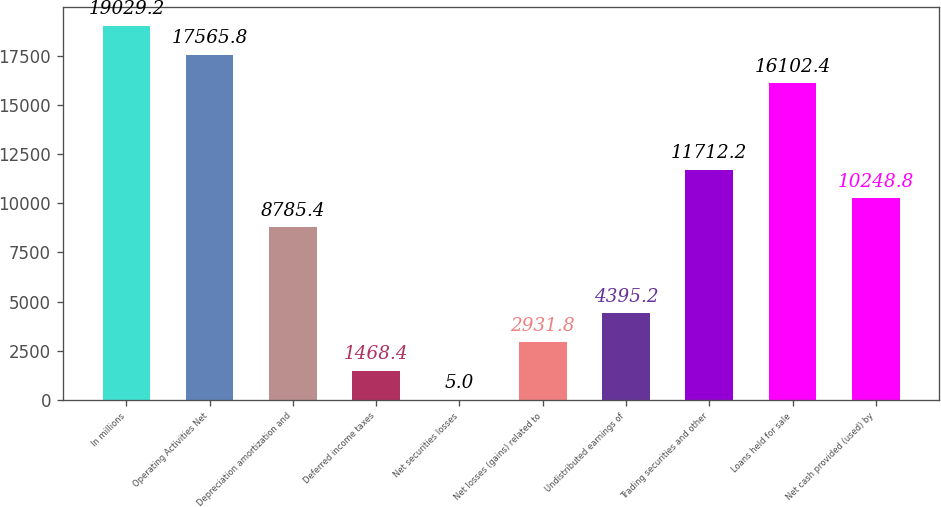Convert chart. <chart><loc_0><loc_0><loc_500><loc_500><bar_chart><fcel>In millions<fcel>Operating Activities Net<fcel>Depreciation amortization and<fcel>Deferred income taxes<fcel>Net securities losses<fcel>Net losses (gains) related to<fcel>Undistributed earnings of<fcel>Trading securities and other<fcel>Loans held for sale<fcel>Net cash provided (used) by<nl><fcel>19029.2<fcel>17565.8<fcel>8785.4<fcel>1468.4<fcel>5<fcel>2931.8<fcel>4395.2<fcel>11712.2<fcel>16102.4<fcel>10248.8<nl></chart> 